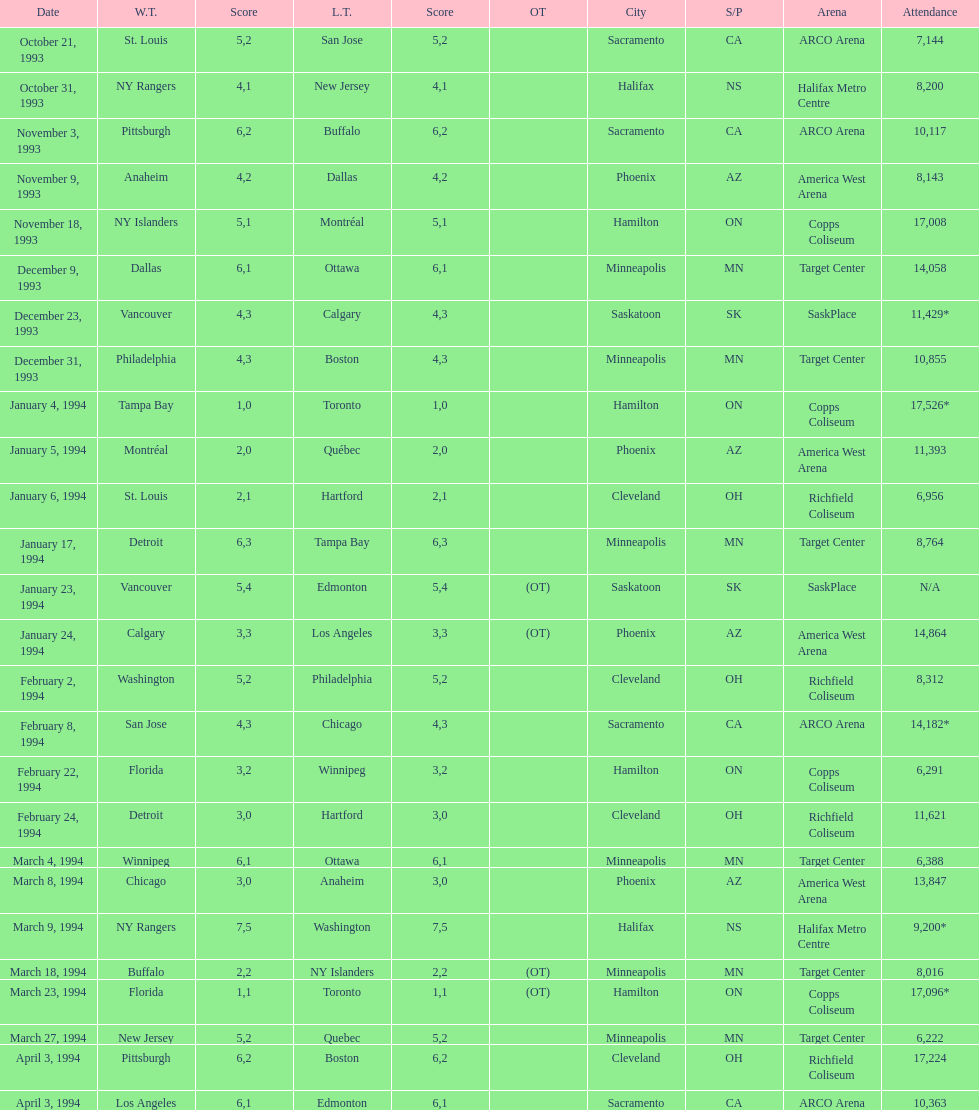How many more attendees were present at the november 18, 1993 games than at the november 9th game? 8865. 